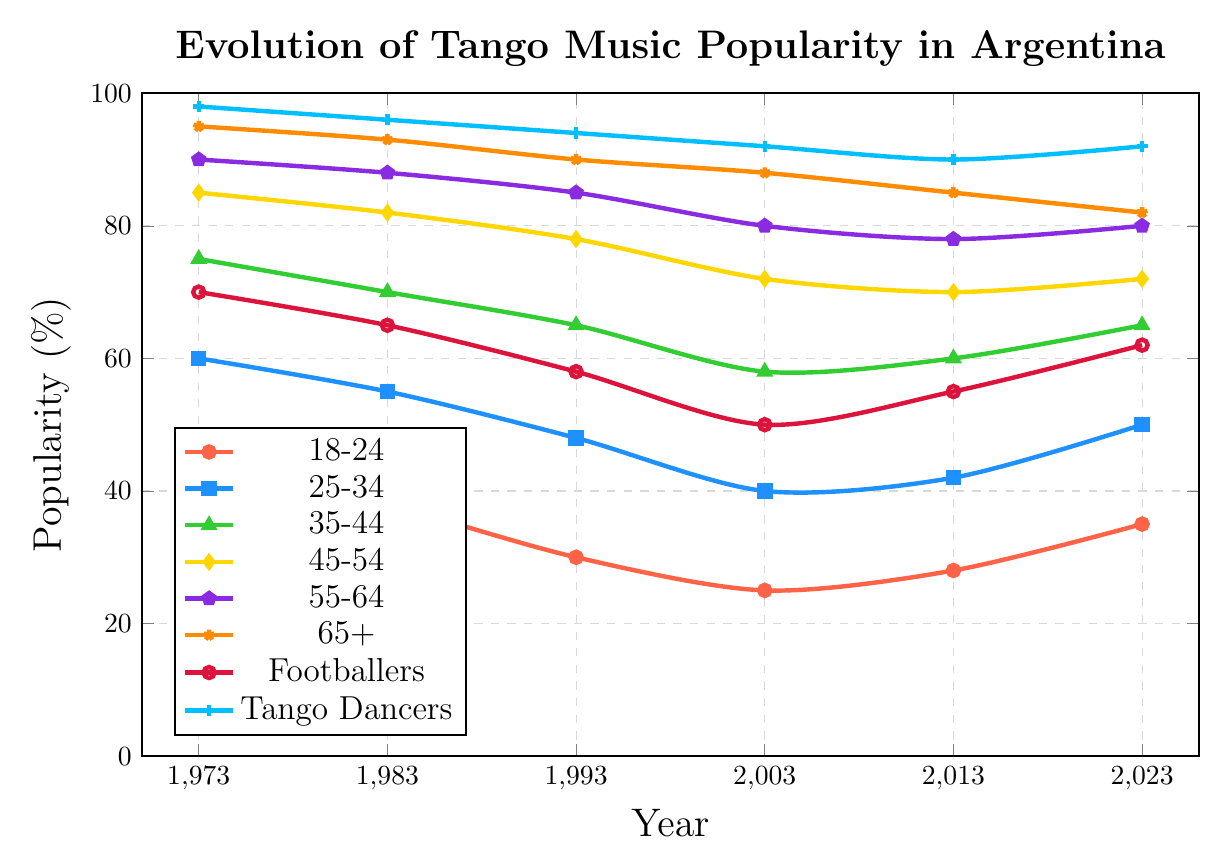What age group has the highest popularity of tango music in 2023 for non-footballers and non-tango dancers? To find the highest popularity in 2023 for non-footballer and non-tango dancer age groups, observe the data points for each age group. 65+ has the highest popularity among these non-excluding groups in 2023 with 82%.
Answer: 65+ How has the popularity of tango music among the 18-24 age group changed from 1973 to 2023? To determine the change, subtract the popularity value in 1973 from the value in 2023: 35 - 45 = -10. Thus, the popularity has decreased by 10 percentage points.
Answer: Decreased by 10% Which group shows the most significant change in popularity from 1973 to 2023? Calculate the change for each group from 1973 to 2023, then identify the group with the largest numerical difference: 
18-24: -10 
25-34: -10 
35-44: -10 
45-54: -13 
55-64: -10 
65+: -13 
Footballers: -8 
Tango Dancers: -6 
The most significant change is -13, seen in the 45-54 and 65+ age groups.
Answer: 45-54 and 65+ Compare the popularity trends of tango music for footballers and tango dancers between 1973 and 2023. Observe the lines for footballers and tango dancers from 1973 to 2023. Both lines decline, but tango dancers maintain a higher level throughout. Footballers’ popularity dropped from 70 to 62, and tango dancers from 98 to 92.
Answer: Tango dancers remained more popular Which age group had the smallest change in popularity from 1973 to 2023? Calculate the change for each age group: 
18-24: -10 
25-34: -10 
35-44: -10 
45-54: -13 
55-64: -10 
65+: -13 
Footballers: -8 
Tango Dancers: -6 
The smallest change is -6, seen in Tango Dancers.
Answer: Tango Dancers What is the trend of tango music popularity among the 35-44 age group from 1973 to 2023? Examine the line plot for the 35-44 age group. The popularity declines steadily from 1973 (75) to 1993 (65), then stabilizes between 2003 (58) to 2023 (65).
Answer: Generally declining, then stabilizing 